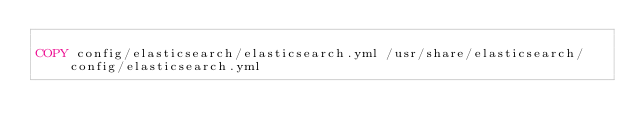<code> <loc_0><loc_0><loc_500><loc_500><_Dockerfile_>
COPY config/elasticsearch/elasticsearch.yml /usr/share/elasticsearch/config/elasticsearch.yml
</code> 